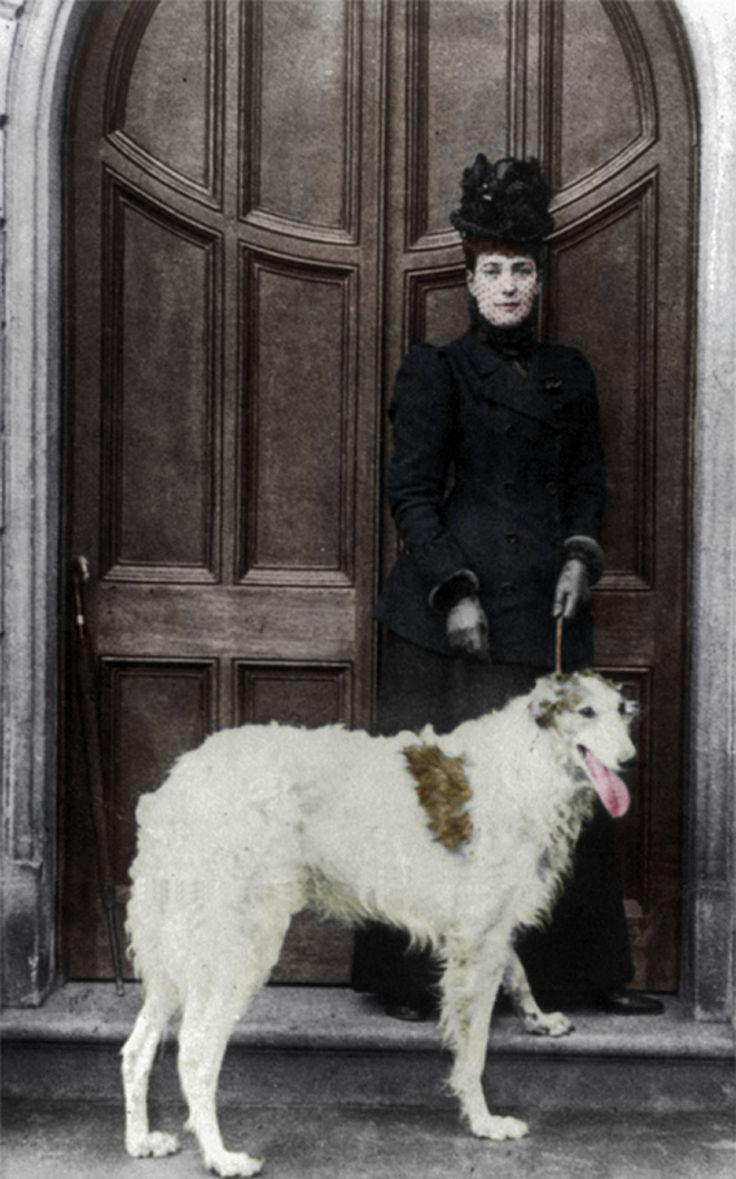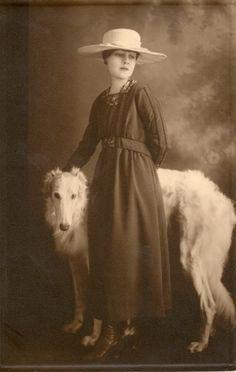The first image is the image on the left, the second image is the image on the right. Assess this claim about the two images: "In one image, a woman wearing a long dark dress with long sleeves is posed for a studio portrait with her hand on the head of a large white dog.". Correct or not? Answer yes or no. Yes. The first image is the image on the left, the second image is the image on the right. For the images shown, is this caption "The left image shows a woman in black standing behind one white hound." true? Answer yes or no. Yes. 